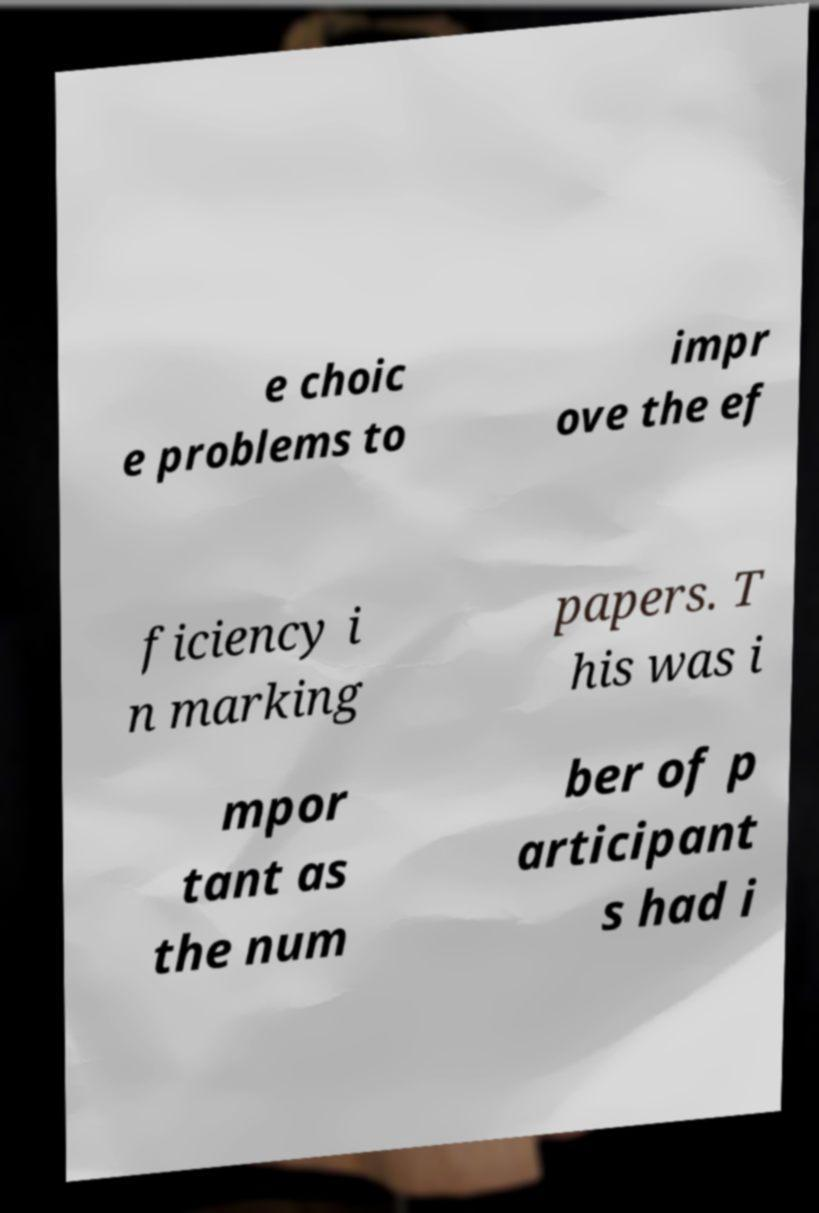Could you assist in decoding the text presented in this image and type it out clearly? e choic e problems to impr ove the ef ficiency i n marking papers. T his was i mpor tant as the num ber of p articipant s had i 